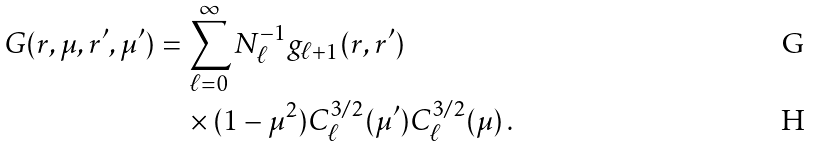Convert formula to latex. <formula><loc_0><loc_0><loc_500><loc_500>G ( r , \mu , r ^ { \prime } , \mu ^ { \prime } ) & = \sum _ { \ell = 0 } ^ { \infty } N _ { \ell } ^ { - 1 } g _ { \ell + 1 } ( r , r ^ { \prime } ) \\ & \quad \times ( 1 - \mu ^ { 2 } ) C _ { \ell } ^ { 3 / 2 } ( \mu ^ { \prime } ) C _ { \ell } ^ { 3 / 2 } ( \mu ) \, .</formula> 